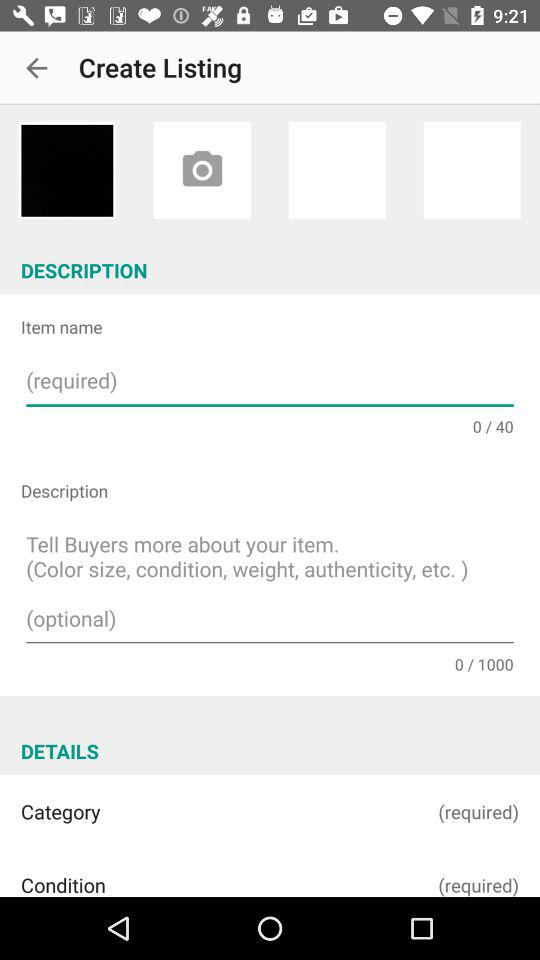What is the maximum character limit for an item name? The maximum character limit for an item name is 40. 